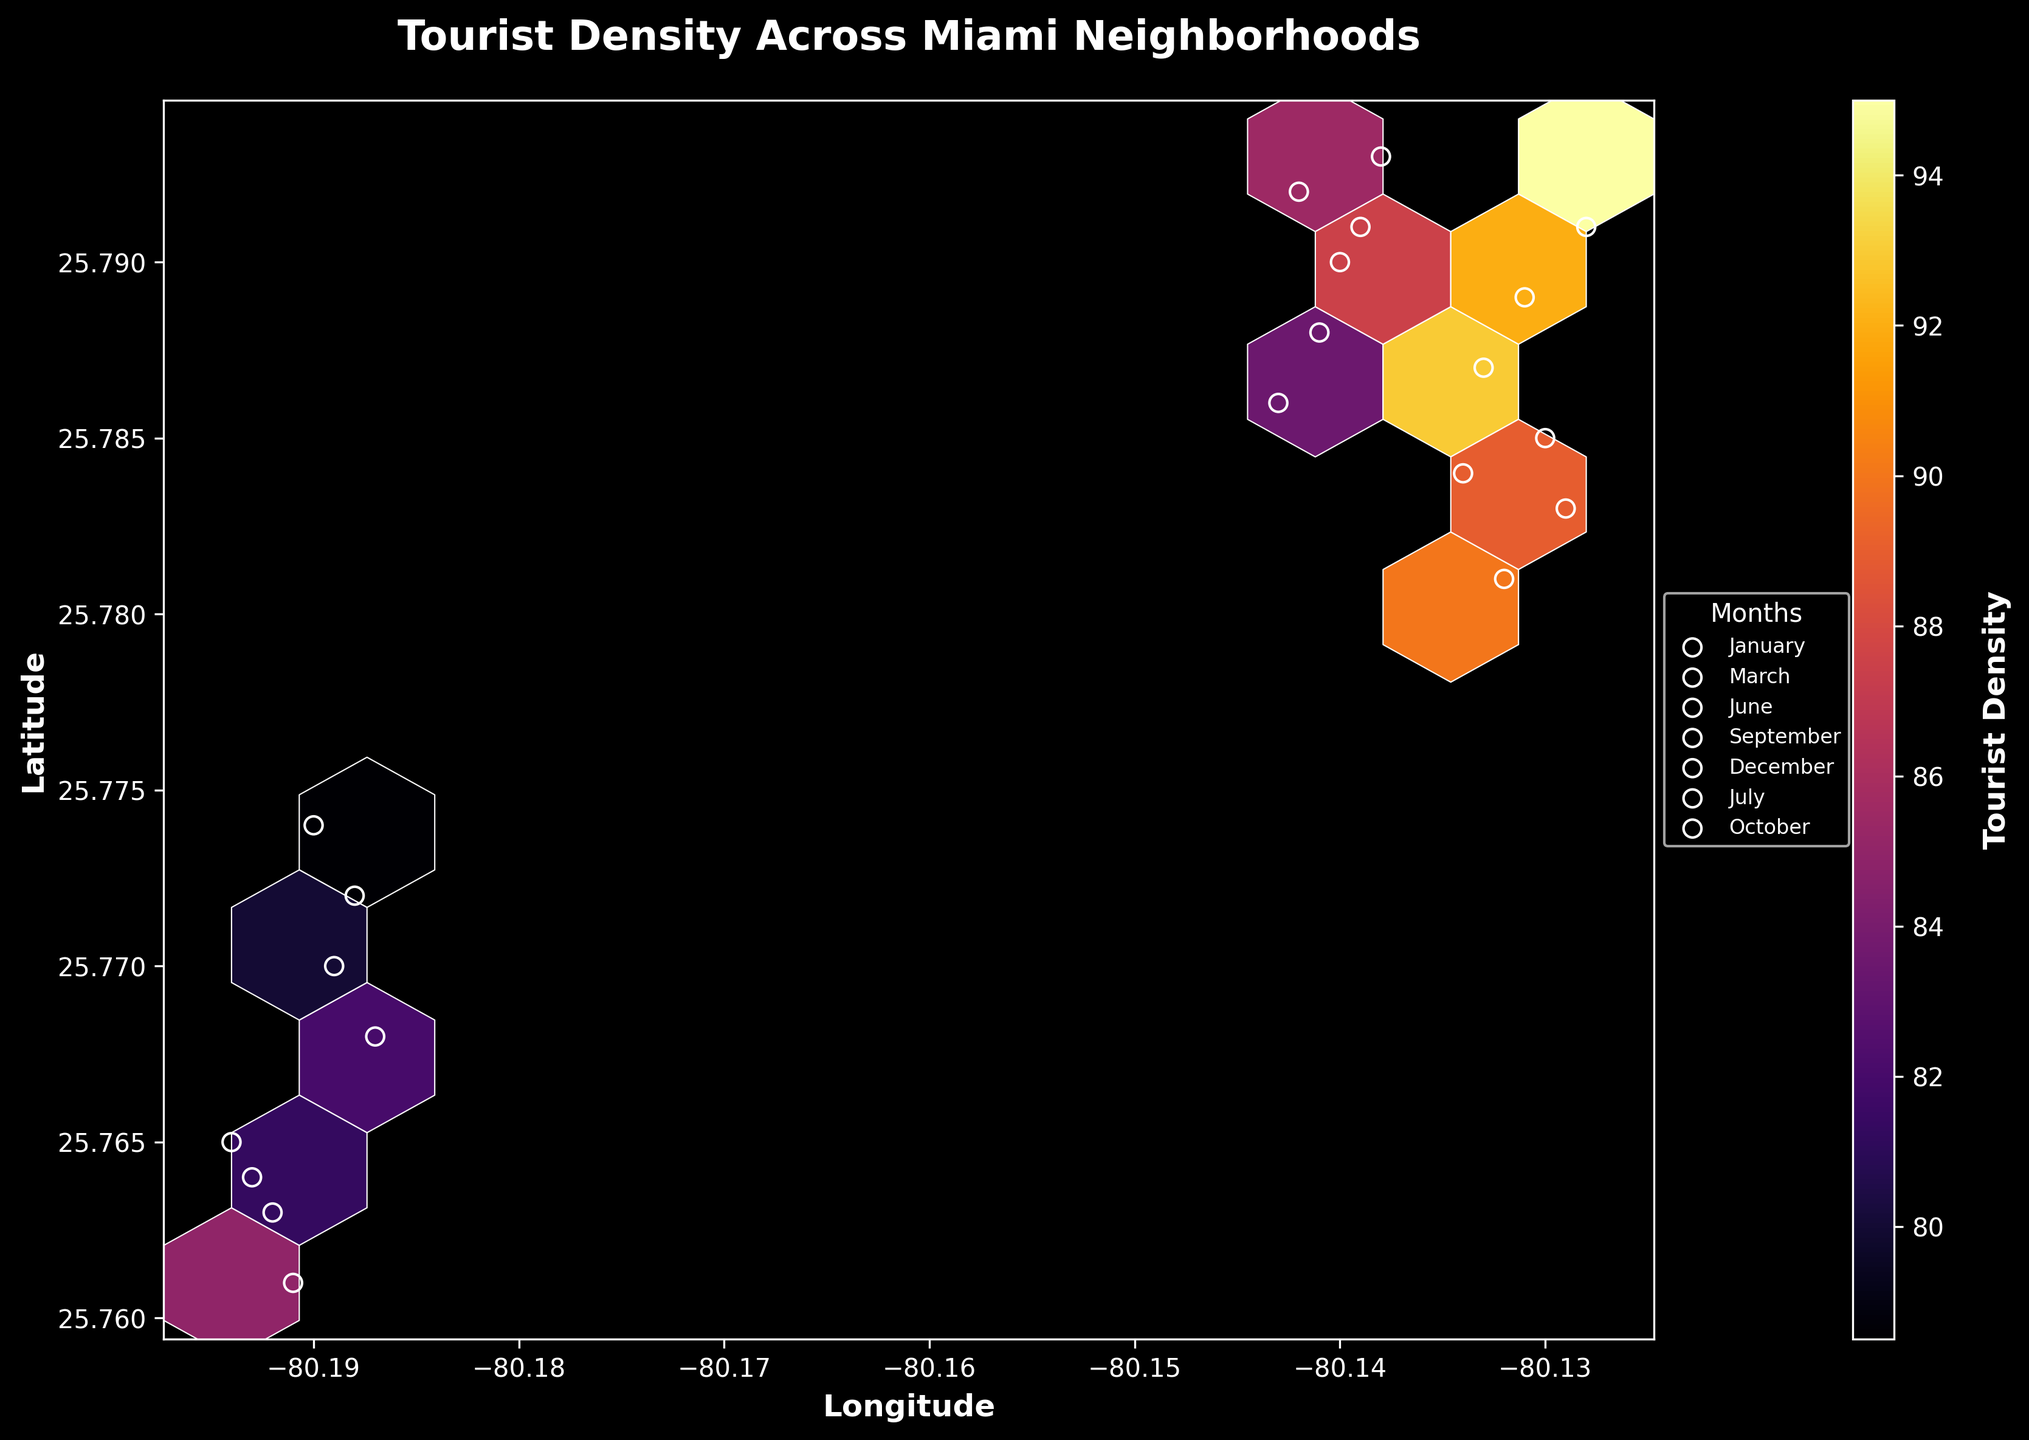What's the title of the plot? The title of the plot is displayed at the top of the figure.
Answer: Tourist Density Across Miami Neighborhoods What do the colors in the hexbin plot represent? The colors in the hexbin plot represent the tourist density, with the color intensity corresponding to different levels. This can be inferred from the color bar labeled "Tourist Density."
Answer: Tourist Density What is the overall trend of tourist density in Miami neighborhoods? By looking at the color intensity of the hexagons, the trend shows varying densities where certain areas are denser than others, representing hotspots of tourist activity. The color bar helps in understanding this trend.
Answer: Varies across neighborhoods Which month shows the highest tourist density? By observing the different scatter points with white edges representing different months and comparing their color intensities in the corresponding hexagons, one can see that March and December have several high-density areas.
Answer: March or December Which neighborhood has the highest density in January? To determine this, look for the white-edged circles representing January and check their associated hexagons' color intensity. The point at approximately (-80.131, 25.789) has the highest density in January.
Answer: Around (-80.131, 25.789) Are there any months where certain neighborhoods show significant changes in tourist density? One must compare the scatter points for different months and observe the change in color intensity of their corresponding hexagons over the same coordinates.
Answer: Yes, varies by location How does tourist density change from January to June? Compare the color intensities of the hexagons associated with the scatter points of January and June. Generally, there is a slight decrease in density from January to June.
Answer: Slight decrease Which coordinates have the highest tourist density overall? Find the hexagon with the highest color intensity, which indicates the highest tourist density, regardless of the month. The highest density appears around (-80.128, 25.791).
Answer: Around (-80.128, 25.791) Is there any correlation between longitude and tourist density? By observing the plot from left to right (longitude axis), you can see if there is any consistent change in color intensity across the longitude. The densities are spread out, indicating no strong correlation.
Answer: No strong correlation What are the key insights that can be derived from the color bar? The color bar helps translate the hexagon colors into specific density values, showing where tourist concentrations are higher or lower. This allows us to interpret the numerical significance of the visual data.
Answer: Visual indication of density 